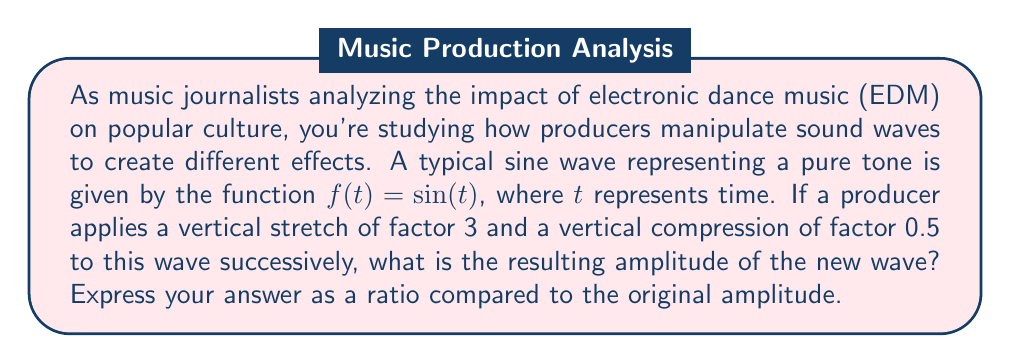Solve this math problem. Let's approach this step-by-step:

1) The original function is $f(t) = \sin(t)$. This sine wave has an amplitude of 1.

2) First, a vertical stretch of factor 3 is applied. This transforms the function to:
   $g(t) = 3\sin(t)$

3) Next, a vertical compression of factor 0.5 is applied to $g(t)$. This results in:
   $h(t) = 0.5(3\sin(t)) = 1.5\sin(t)$

4) The amplitude of a sine wave is the coefficient in front of the sine function. In this case, it's 1.5.

5) To express this as a ratio compared to the original amplitude:
   New amplitude : Original amplitude = 1.5 : 1

6) This can be simplified to 3:2

Therefore, the new amplitude is 1.5 times the original amplitude, or expressed as a ratio, 3:2.
Answer: 3:2 